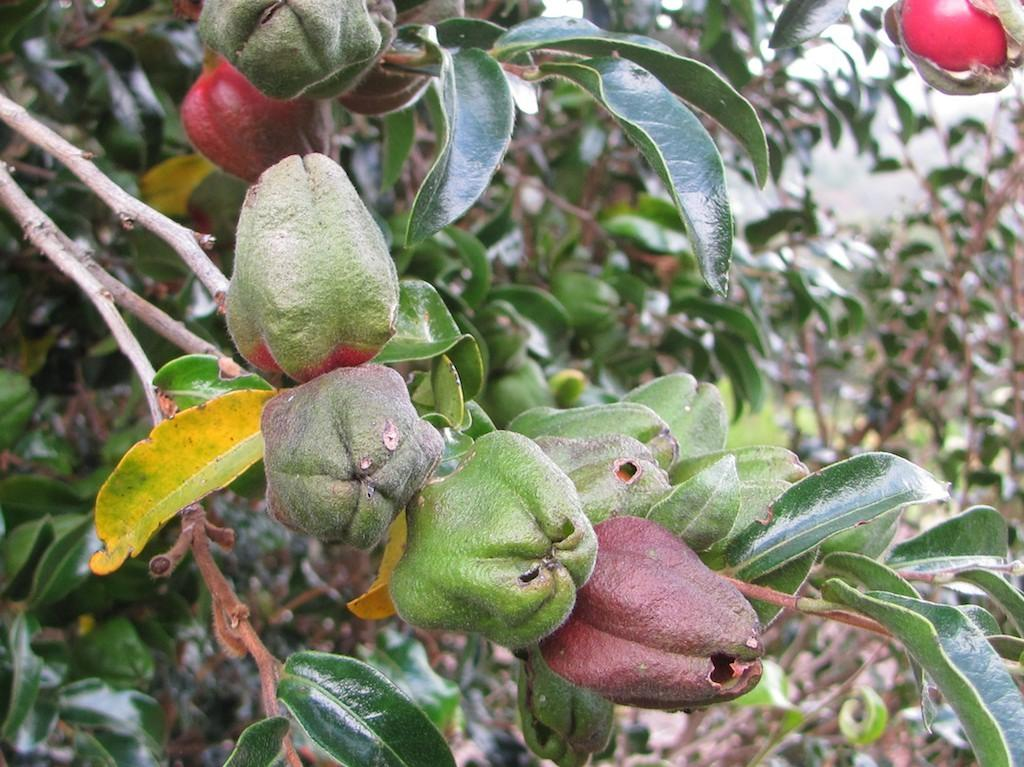What type of living organisms can be seen on the plant in the image? There are fruits on a plant in the image. Are there any other plants visible in the image? Yes, there are other plants visible in the image, although they may be blurry. What type of weather can be seen in the image? There is no information about the weather in the image, as it only shows plants with fruits and other plants. What holiday is being celebrated in the image? There is no indication of a holiday being celebrated in the image. 